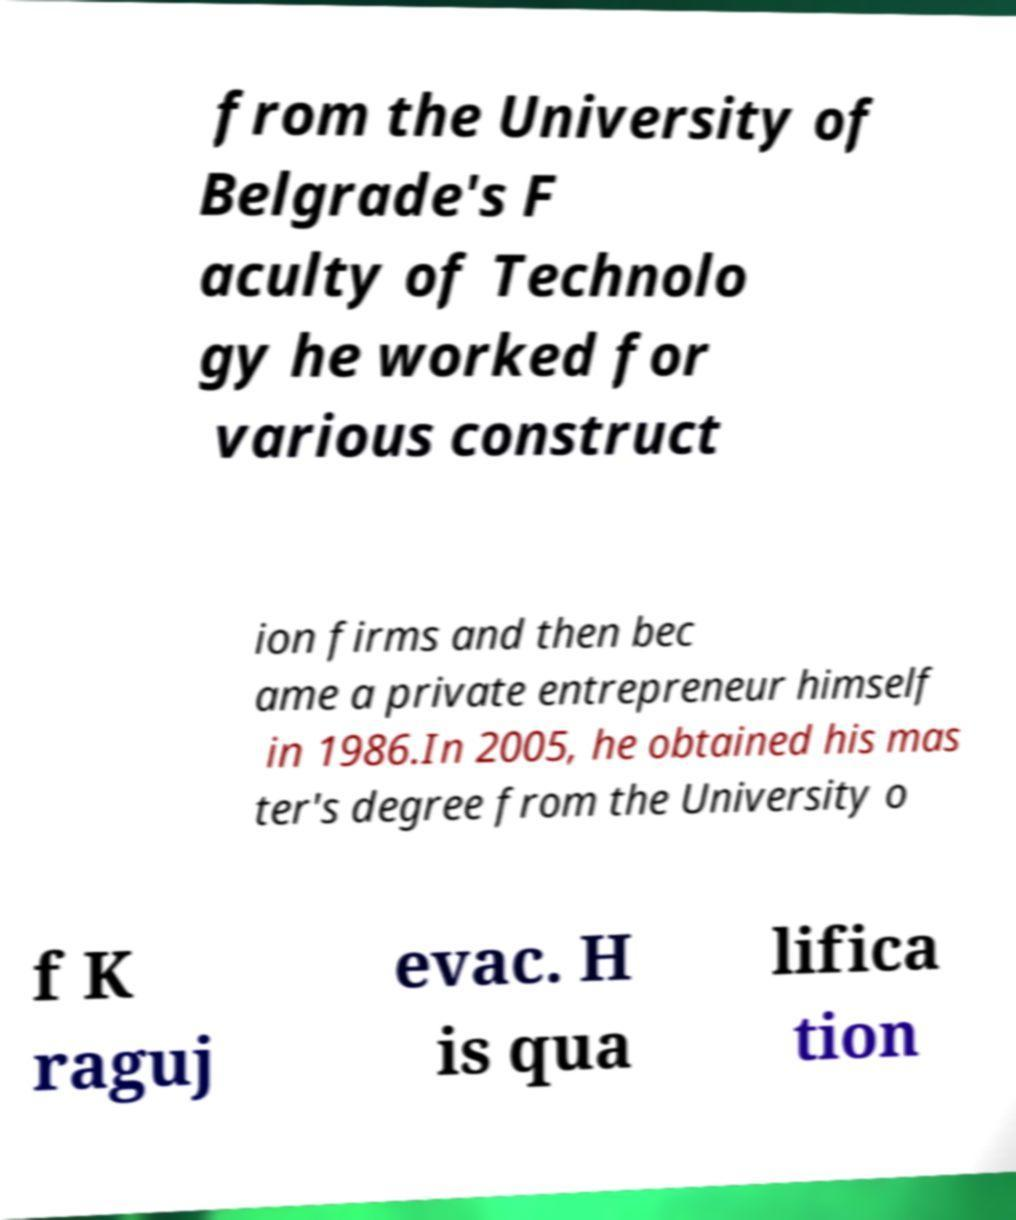Please read and relay the text visible in this image. What does it say? from the University of Belgrade's F aculty of Technolo gy he worked for various construct ion firms and then bec ame a private entrepreneur himself in 1986.In 2005, he obtained his mas ter's degree from the University o f K raguj evac. H is qua lifica tion 